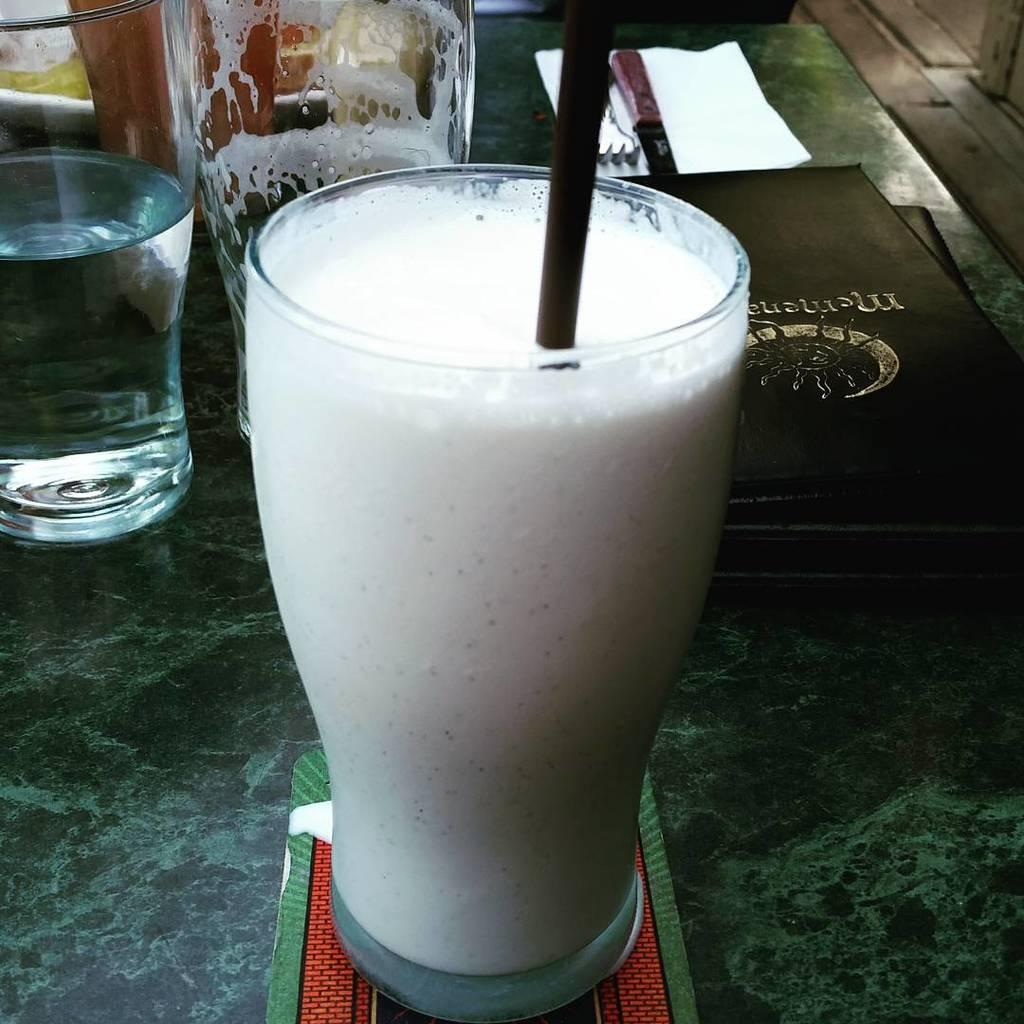What type of container is visible in the image? There is a glass in the image. What is used for drinking in the image? There is a straw in the image. What is the primary reading material in the image? There is a book in the image. What utensil is present in the image? There is a knife and a spoon in the image. What type of paper is present in the image? There is a paper in the image. Where are all these objects located? All these objects are on a table. What type of cord is used to connect the doctor to the sneeze in the image? There is no doctor, sneeze, or cord present in the image. 